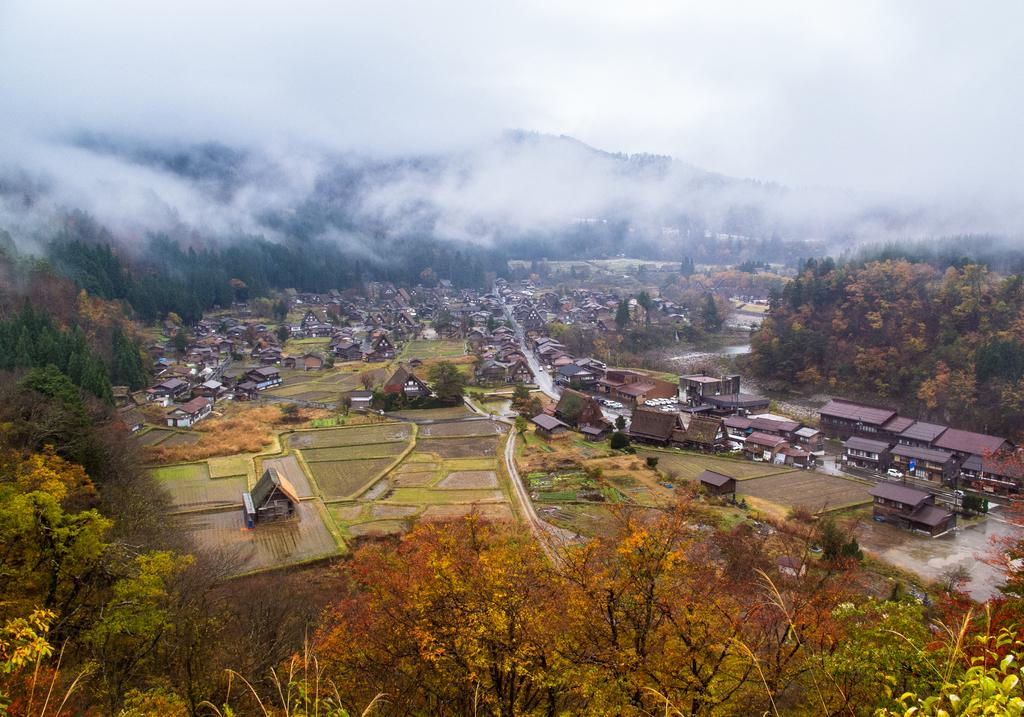What type of vegetation is at the bottom of the image? There are trees at the bottom of the image. What structures are located in the middle of the image? There are houses in the middle of the image. What geographical features can be seen in the background of the image? There are hills in the background of the image. What is visible at the top of the image? The sky is visible at the top of the image. How would you describe the weather based on the appearance of the sky? The sky appears to be cloudy, which might suggest overcast or potentially rainy weather. How many brothers are depicted in the image? There are no people or figures present in the image, so it is impossible to determine the number of brothers. What type of chin can be seen on the trees in the image? There are no chins present in the image, as chins are a facial feature typically associated with humans or animals, and the image only features trees. 